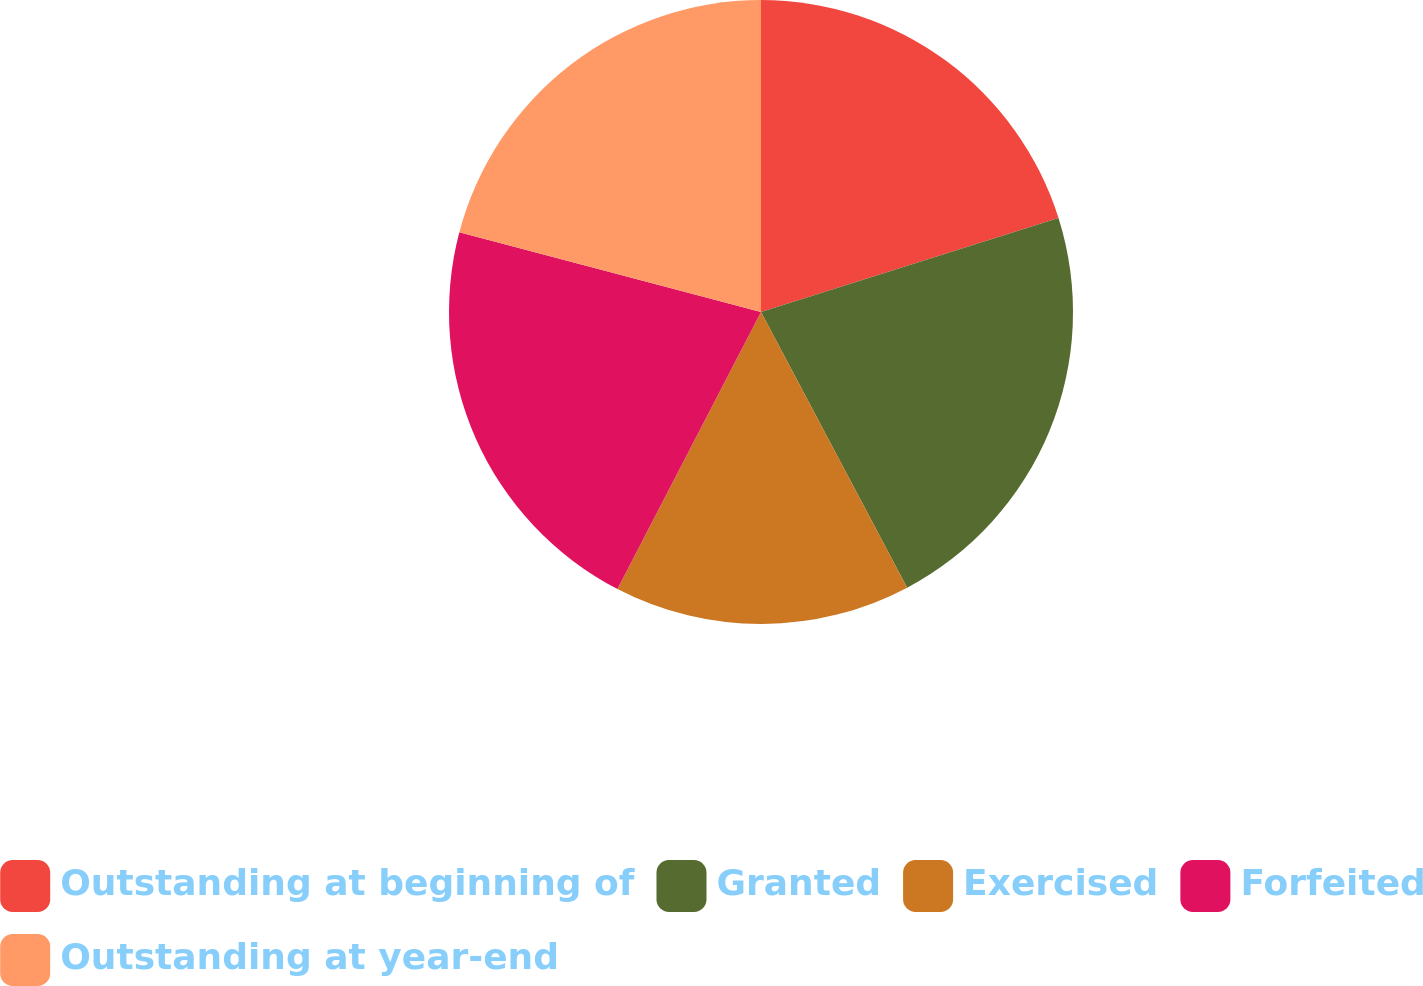Convert chart to OTSL. <chart><loc_0><loc_0><loc_500><loc_500><pie_chart><fcel>Outstanding at beginning of<fcel>Granted<fcel>Exercised<fcel>Forfeited<fcel>Outstanding at year-end<nl><fcel>20.13%<fcel>22.11%<fcel>15.37%<fcel>21.5%<fcel>20.89%<nl></chart> 